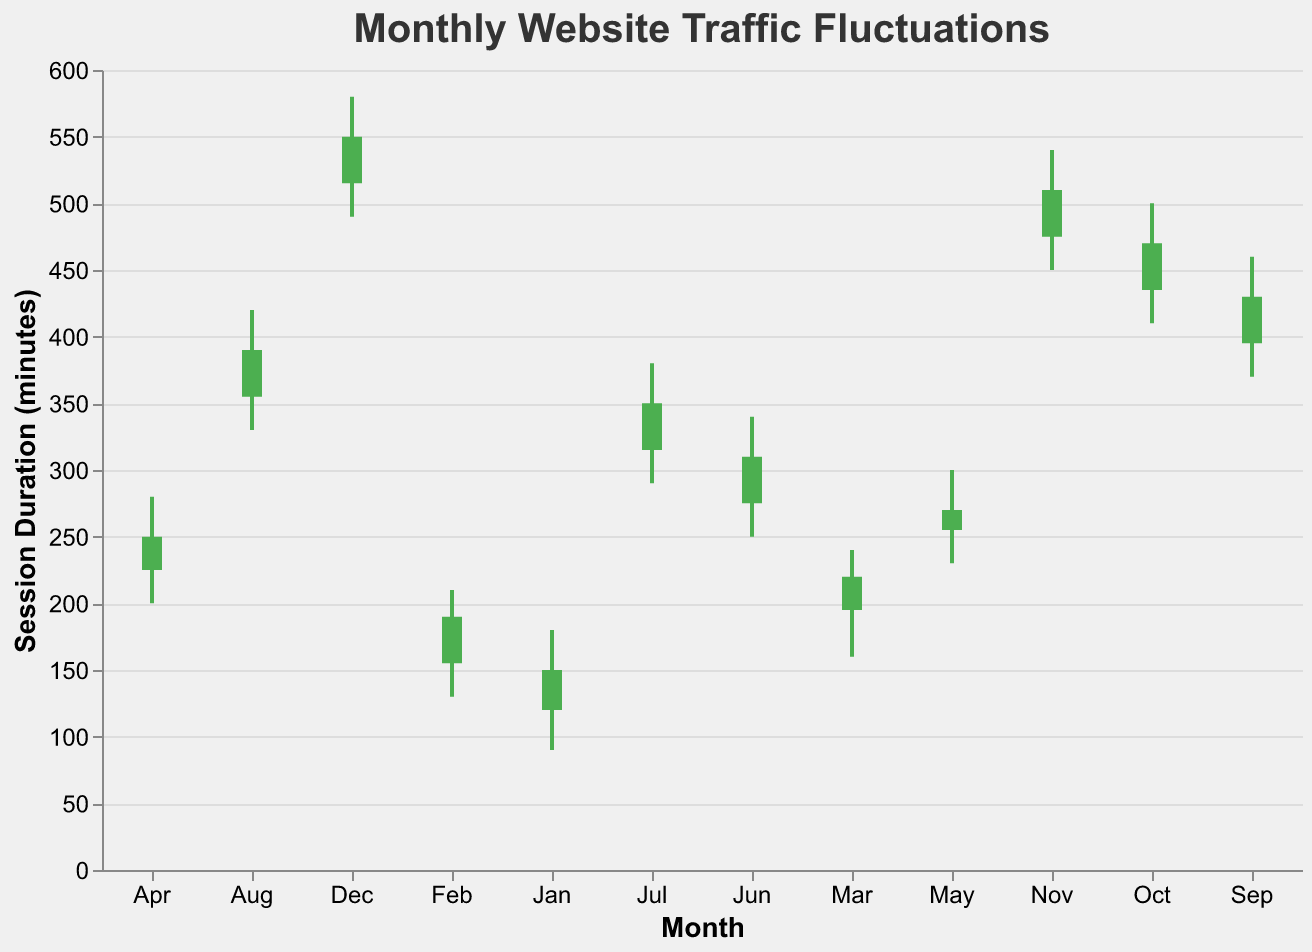What is the highest session duration in December? The highest session duration is represented by the 'High' value in December, which is 580 minutes.
Answer: 580 minutes How does the session duration range in July compare to that in March? The session duration in March ranges from 160 to 240 minutes while in July it ranges from 290 to 380 minutes. July shows a higher range and higher overall session durations.
Answer: July's duration is higher Between which two months did the session duration open at the highest value? By comparing the 'Open' values across all months, December opened at the highest value with 515 minutes. The month before that is November with an open value of 475 minutes.
Answer: November to December What was the lowest session duration recorded in April? The lowest session duration in April, represented by the 'Low' value, is 200 minutes.
Answer: 200 minutes Did the session durations increase or decrease from January to February? From January to February, the 'Open' value increased from 120 to 155 and the 'Close' value increased from 150 to 190, indicating an overall increase.
Answer: Increase What is the total duration difference between the highest and lowest sessions recorded in August? The highest session duration in August is 420 minutes and the lowest is 330 minutes. The difference is 420 - 330 = 90 minutes.
Answer: 90 minutes Which month had the smallest increase in session duration from opening to closing? To find the smallest increase, subtract the 'Open' value from the 'Close' value for each month. February: 35 minutes, March: 25 minutes, April: 25 minutes, etc. March and April both have the smallest increase of 25 minutes.
Answer: March and April Which month saw the largest fluctuation in session durations? The largest fluctuation is seen by looking at the range High - Low for each month. October has the largest fluctuation with 500 - 410 = 90 minutes.
Answer: October In which month did the session duration close at exactly 270 minutes? Looking at the 'Close' values for each month, May had a closing session duration of exactly 270 minutes.
Answer: May 